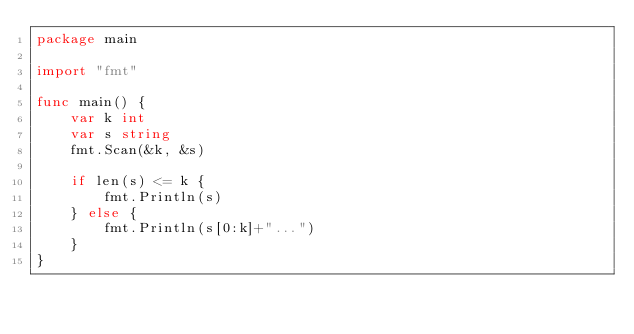<code> <loc_0><loc_0><loc_500><loc_500><_Go_>package main

import "fmt"

func main() {
	var k int
	var s string
	fmt.Scan(&k, &s)

	if len(s) <= k {
		fmt.Println(s)
	} else {
		fmt.Println(s[0:k]+"...")
	}
}
</code> 